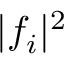<formula> <loc_0><loc_0><loc_500><loc_500>| f _ { i } | ^ { 2 }</formula> 